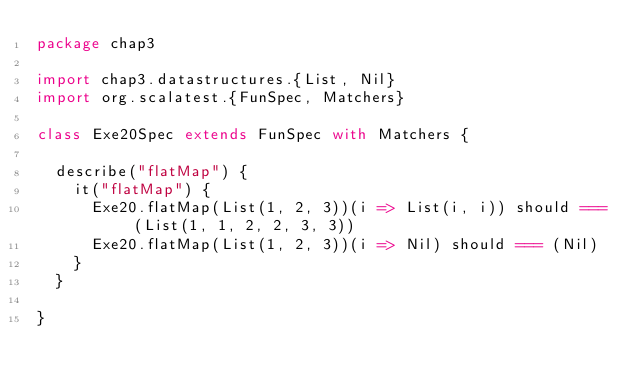Convert code to text. <code><loc_0><loc_0><loc_500><loc_500><_Scala_>package chap3

import chap3.datastructures.{List, Nil}
import org.scalatest.{FunSpec, Matchers}

class Exe20Spec extends FunSpec with Matchers {

  describe("flatMap") {
    it("flatMap") {
      Exe20.flatMap(List(1, 2, 3))(i => List(i, i)) should === (List(1, 1, 2, 2, 3, 3))
      Exe20.flatMap(List(1, 2, 3))(i => Nil) should === (Nil)
    }
  }

}
</code> 